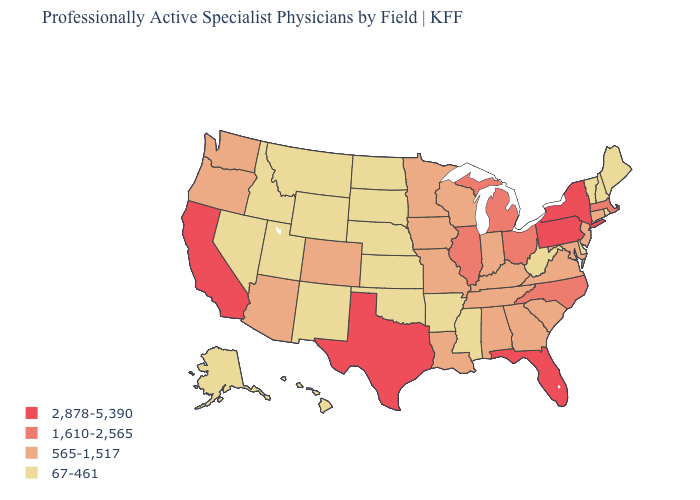What is the lowest value in the South?
Give a very brief answer. 67-461. What is the value of Montana?
Give a very brief answer. 67-461. Name the states that have a value in the range 67-461?
Answer briefly. Alaska, Arkansas, Delaware, Hawaii, Idaho, Kansas, Maine, Mississippi, Montana, Nebraska, Nevada, New Hampshire, New Mexico, North Dakota, Oklahoma, Rhode Island, South Dakota, Utah, Vermont, West Virginia, Wyoming. Among the states that border Massachusetts , does Vermont have the lowest value?
Be succinct. Yes. What is the value of Maine?
Write a very short answer. 67-461. Name the states that have a value in the range 565-1,517?
Answer briefly. Alabama, Arizona, Colorado, Connecticut, Georgia, Indiana, Iowa, Kentucky, Louisiana, Maryland, Minnesota, Missouri, New Jersey, Oregon, South Carolina, Tennessee, Virginia, Washington, Wisconsin. Does Iowa have the lowest value in the MidWest?
Quick response, please. No. Which states hav the highest value in the MidWest?
Keep it brief. Illinois, Michigan, Ohio. What is the highest value in the USA?
Write a very short answer. 2,878-5,390. What is the lowest value in the USA?
Answer briefly. 67-461. Does Kansas have the lowest value in the MidWest?
Concise answer only. Yes. What is the highest value in the South ?
Be succinct. 2,878-5,390. Name the states that have a value in the range 1,610-2,565?
Concise answer only. Illinois, Massachusetts, Michigan, North Carolina, Ohio. What is the lowest value in the South?
Give a very brief answer. 67-461. What is the value of New Jersey?
Keep it brief. 565-1,517. 